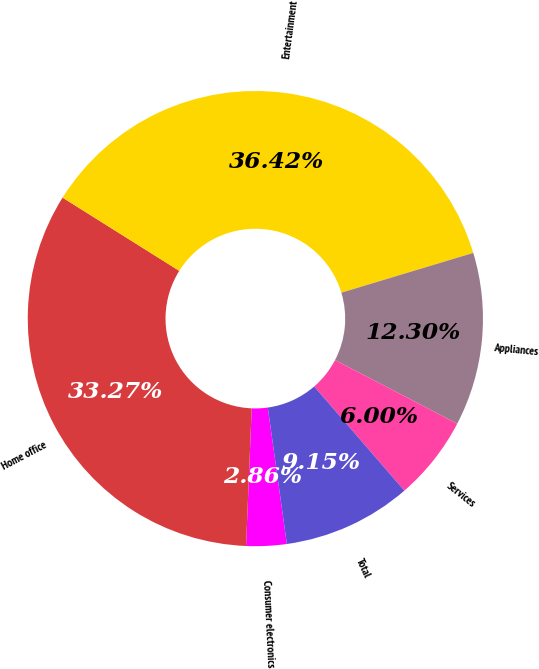<chart> <loc_0><loc_0><loc_500><loc_500><pie_chart><fcel>Consumer electronics<fcel>Home office<fcel>Entertainment<fcel>Appliances<fcel>Services<fcel>Total<nl><fcel>2.86%<fcel>33.27%<fcel>36.42%<fcel>12.3%<fcel>6.0%<fcel>9.15%<nl></chart> 